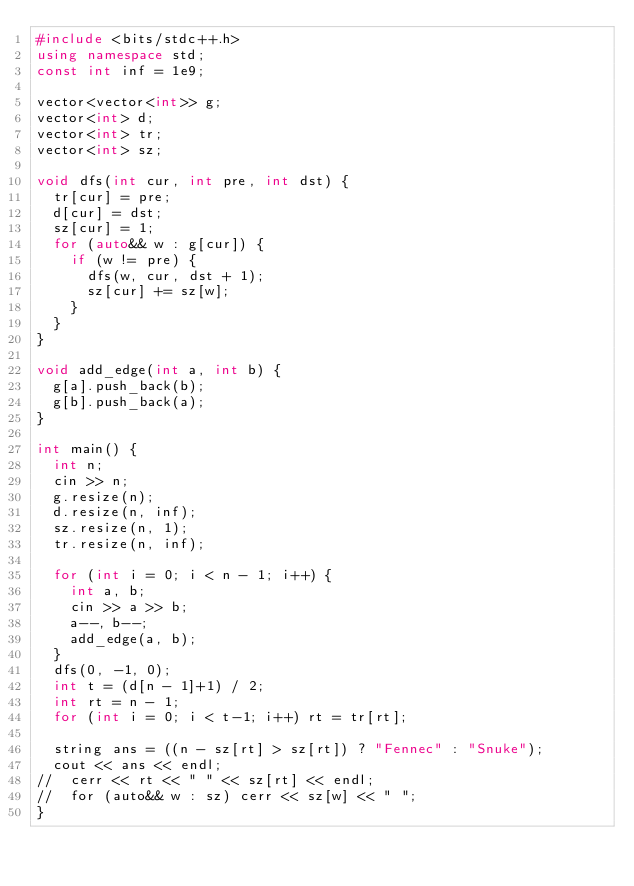Convert code to text. <code><loc_0><loc_0><loc_500><loc_500><_C++_>#include <bits/stdc++.h>
using namespace std;
const int inf = 1e9;

vector<vector<int>> g;
vector<int> d;
vector<int> tr;
vector<int> sz;

void dfs(int cur, int pre, int dst) {
  tr[cur] = pre;
  d[cur] = dst;
  sz[cur] = 1;
  for (auto&& w : g[cur]) {
    if (w != pre) {
      dfs(w, cur, dst + 1);
      sz[cur] += sz[w];
    }
  }
}

void add_edge(int a, int b) {
  g[a].push_back(b);
  g[b].push_back(a);
}

int main() {
  int n;
  cin >> n;
  g.resize(n);
  d.resize(n, inf);
  sz.resize(n, 1);
  tr.resize(n, inf);

  for (int i = 0; i < n - 1; i++) {
    int a, b;
    cin >> a >> b;
    a--, b--;
    add_edge(a, b);
  }
  dfs(0, -1, 0);
  int t = (d[n - 1]+1) / 2;
  int rt = n - 1;
  for (int i = 0; i < t-1; i++) rt = tr[rt];

  string ans = ((n - sz[rt] > sz[rt]) ? "Fennec" : "Snuke");
  cout << ans << endl;
//  cerr << rt << " " << sz[rt] << endl;
//  for (auto&& w : sz) cerr << sz[w] << " ";
}
</code> 